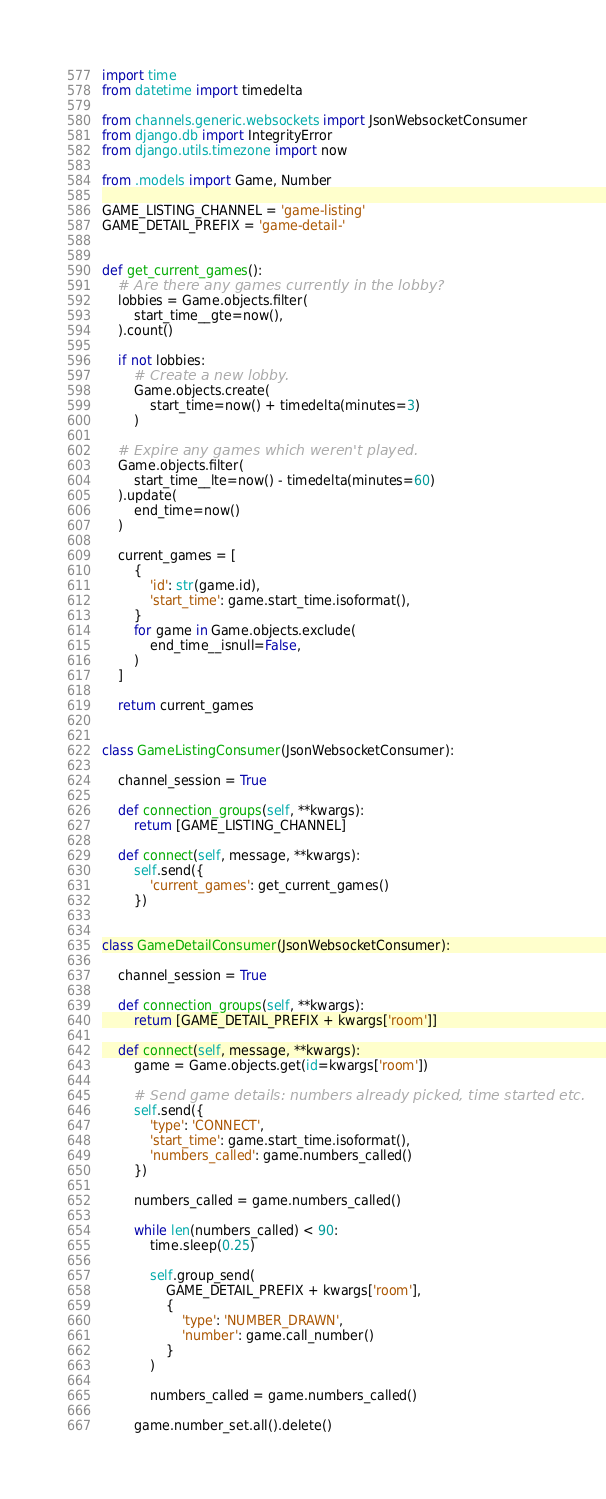<code> <loc_0><loc_0><loc_500><loc_500><_Python_>import time
from datetime import timedelta

from channels.generic.websockets import JsonWebsocketConsumer
from django.db import IntegrityError
from django.utils.timezone import now

from .models import Game, Number

GAME_LISTING_CHANNEL = 'game-listing'
GAME_DETAIL_PREFIX = 'game-detail-'


def get_current_games():
    # Are there any games currently in the lobby?
    lobbies = Game.objects.filter(
        start_time__gte=now(),
    ).count()

    if not lobbies:
        # Create a new lobby.
        Game.objects.create(
            start_time=now() + timedelta(minutes=3)
        )

    # Expire any games which weren't played.
    Game.objects.filter(
        start_time__lte=now() - timedelta(minutes=60)
    ).update(
        end_time=now()
    )

    current_games = [
        {
            'id': str(game.id),
            'start_time': game.start_time.isoformat(),
        }
        for game in Game.objects.exclude(
            end_time__isnull=False,
        )
    ]

    return current_games


class GameListingConsumer(JsonWebsocketConsumer):

    channel_session = True

    def connection_groups(self, **kwargs):
        return [GAME_LISTING_CHANNEL]

    def connect(self, message, **kwargs):
        self.send({
            'current_games': get_current_games()
        })


class GameDetailConsumer(JsonWebsocketConsumer):

    channel_session = True

    def connection_groups(self, **kwargs):
        return [GAME_DETAIL_PREFIX + kwargs['room']]

    def connect(self, message, **kwargs):
        game = Game.objects.get(id=kwargs['room'])

        # Send game details: numbers already picked, time started etc.
        self.send({
            'type': 'CONNECT',
            'start_time': game.start_time.isoformat(),
            'numbers_called': game.numbers_called()
        })

        numbers_called = game.numbers_called()

        while len(numbers_called) < 90:
            time.sleep(0.25)

            self.group_send(
                GAME_DETAIL_PREFIX + kwargs['room'],
                {
                    'type': 'NUMBER_DRAWN',
                    'number': game.call_number()
                }
            )

            numbers_called = game.numbers_called()

        game.number_set.all().delete()
</code> 